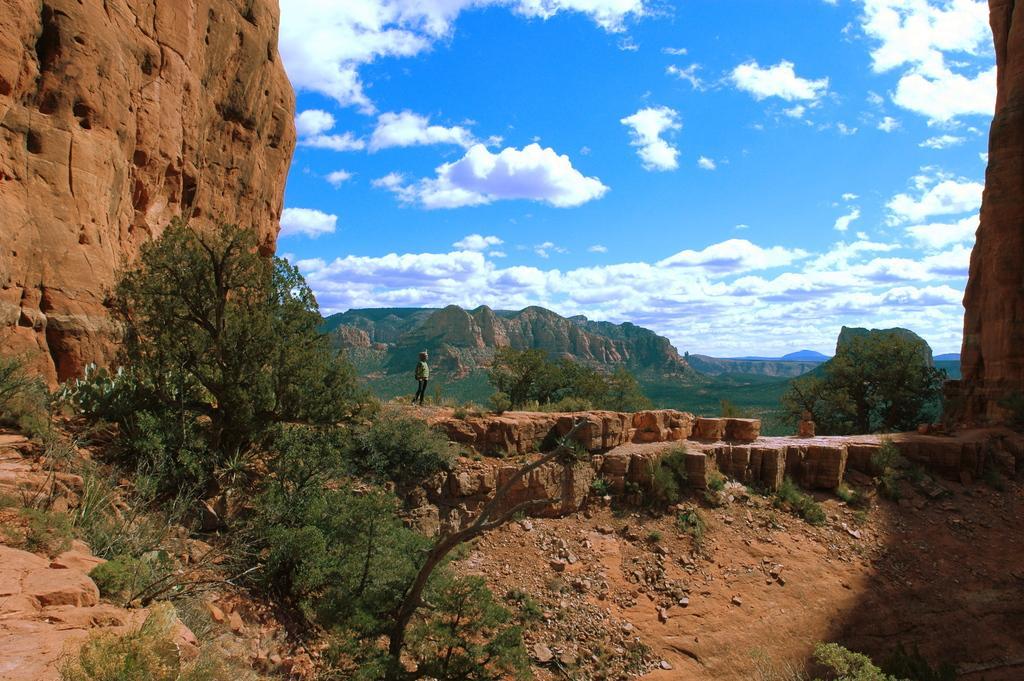Can you describe this image briefly? This is an outside view. In this image, I can see many rocks and trees. In the middle of the image there is a person standing. In the background there are many rocky mountains. At the top of the image, I can see the sky and clouds. 